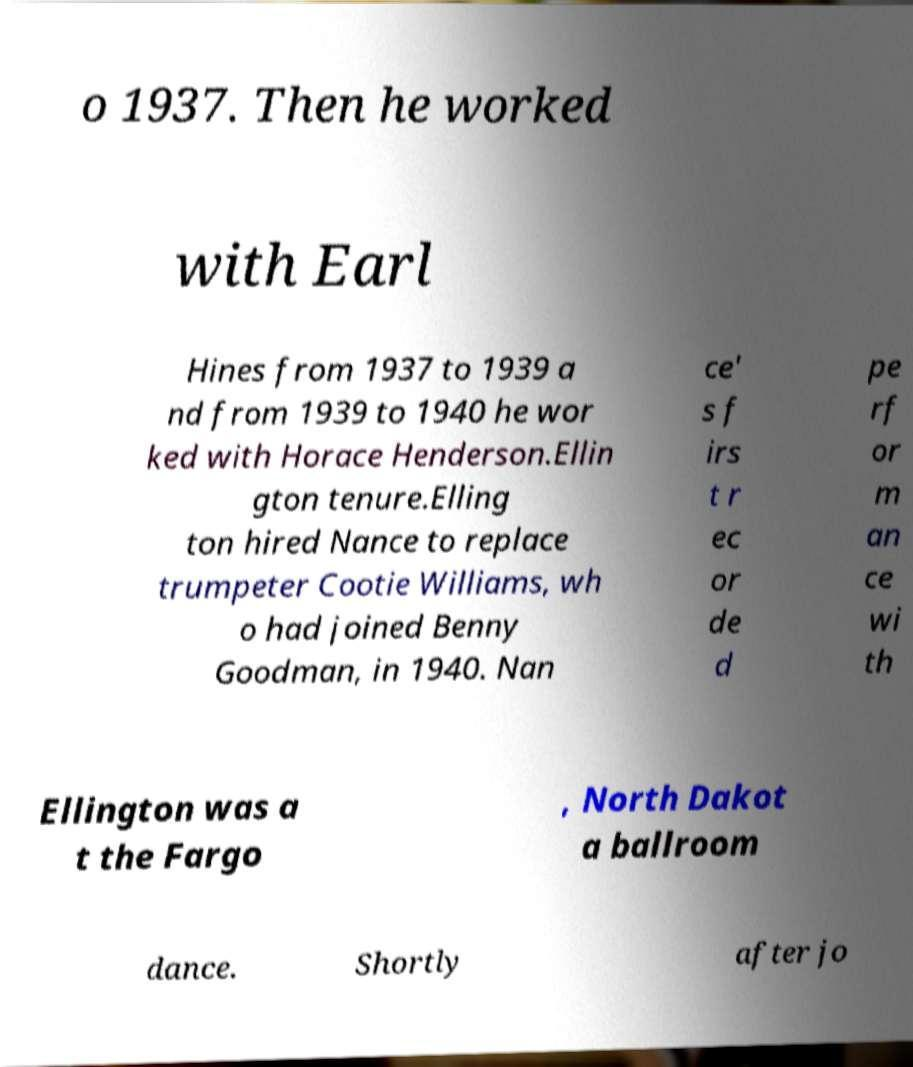What messages or text are displayed in this image? I need them in a readable, typed format. o 1937. Then he worked with Earl Hines from 1937 to 1939 a nd from 1939 to 1940 he wor ked with Horace Henderson.Ellin gton tenure.Elling ton hired Nance to replace trumpeter Cootie Williams, wh o had joined Benny Goodman, in 1940. Nan ce' s f irs t r ec or de d pe rf or m an ce wi th Ellington was a t the Fargo , North Dakot a ballroom dance. Shortly after jo 